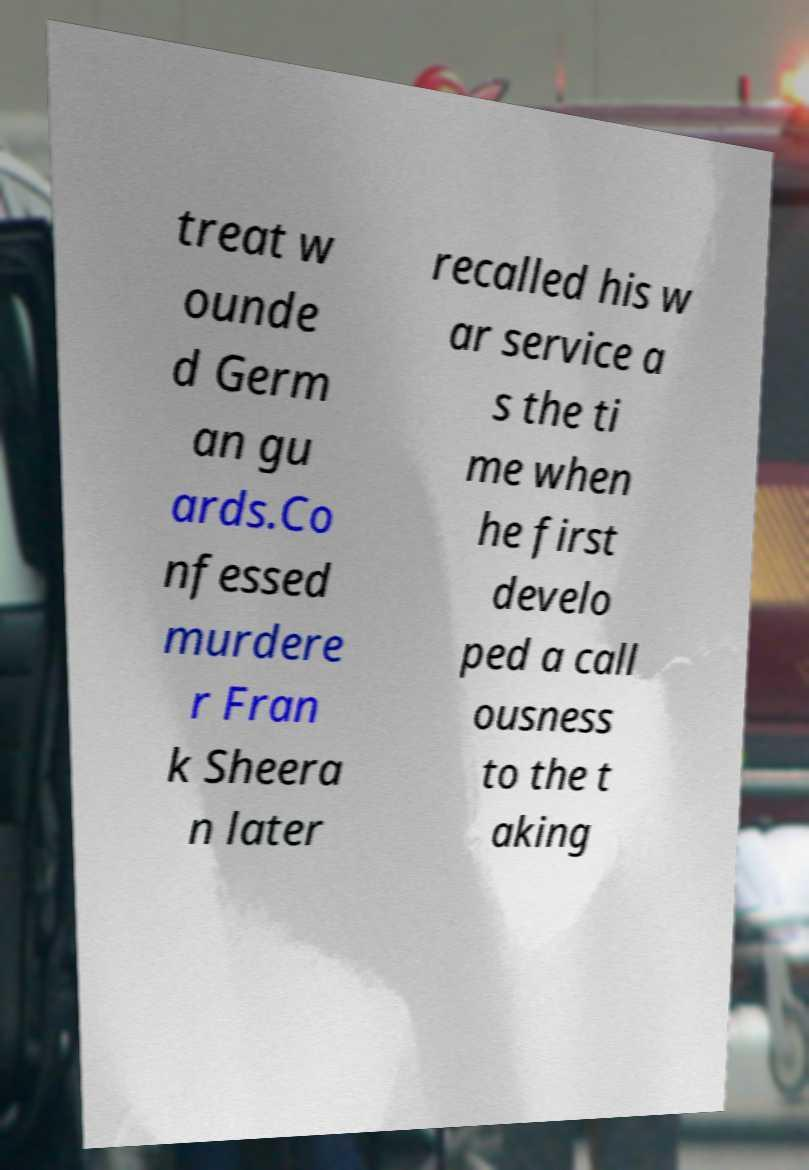There's text embedded in this image that I need extracted. Can you transcribe it verbatim? treat w ounde d Germ an gu ards.Co nfessed murdere r Fran k Sheera n later recalled his w ar service a s the ti me when he first develo ped a call ousness to the t aking 